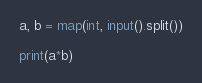Convert code to text. <code><loc_0><loc_0><loc_500><loc_500><_Python_>a, b = map(int, input().split())

print(a*b)</code> 